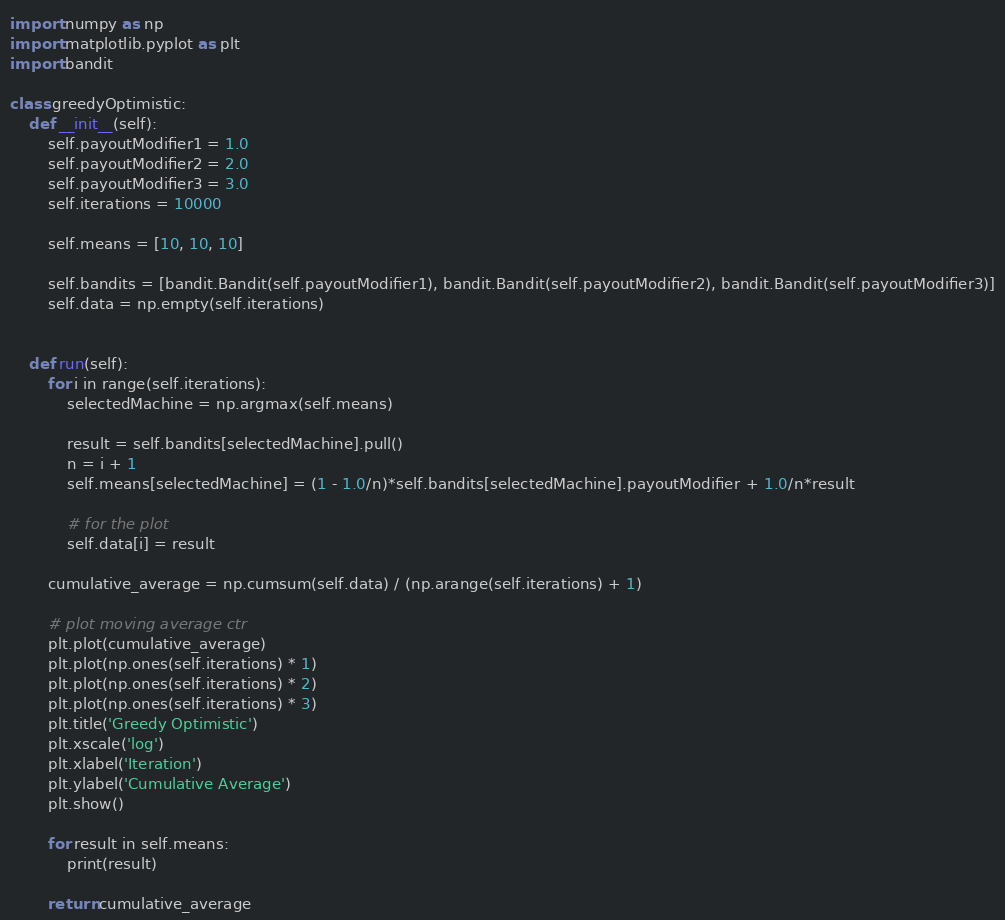<code> <loc_0><loc_0><loc_500><loc_500><_Python_>import numpy as np
import matplotlib.pyplot as plt
import bandit

class greedyOptimistic:
    def __init__(self):
        self.payoutModifier1 = 1.0
        self.payoutModifier2 = 2.0
        self.payoutModifier3 = 3.0
        self.iterations = 10000

        self.means = [10, 10, 10]

        self.bandits = [bandit.Bandit(self.payoutModifier1), bandit.Bandit(self.payoutModifier2), bandit.Bandit(self.payoutModifier3)]
        self.data = np.empty(self.iterations)
        

    def run(self):
        for i in range(self.iterations):
            selectedMachine = np.argmax(self.means)

            result = self.bandits[selectedMachine].pull()
            n = i + 1
            self.means[selectedMachine] = (1 - 1.0/n)*self.bandits[selectedMachine].payoutModifier + 1.0/n*result

            # for the plot
            self.data[i] = result

        cumulative_average = np.cumsum(self.data) / (np.arange(self.iterations) + 1)

        # plot moving average ctr
        plt.plot(cumulative_average)
        plt.plot(np.ones(self.iterations) * 1)
        plt.plot(np.ones(self.iterations) * 2)
        plt.plot(np.ones(self.iterations) * 3)
        plt.title('Greedy Optimistic')
        plt.xscale('log')
        plt.xlabel('Iteration')
        plt.ylabel('Cumulative Average')
        plt.show()

        for result in self.means:
            print(result)

        return cumulative_average</code> 